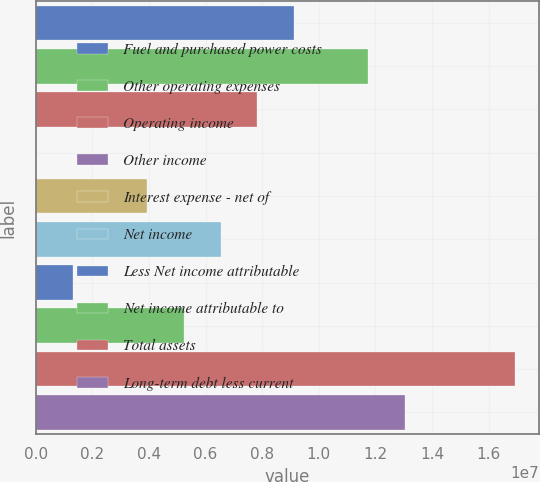Convert chart. <chart><loc_0><loc_0><loc_500><loc_500><bar_chart><fcel>Fuel and purchased power costs<fcel>Other operating expenses<fcel>Operating income<fcel>Other income<fcel>Interest expense - net of<fcel>Net income<fcel>Less Net income attributable<fcel>Net income attributable to<fcel>Total assets<fcel>Long-term debt less current<nl><fcel>9.13006e+06<fcel>1.17315e+07<fcel>7.82933e+06<fcel>24974<fcel>3.92715e+06<fcel>6.52861e+06<fcel>1.3257e+06<fcel>5.22788e+06<fcel>1.69344e+07<fcel>1.30322e+07<nl></chart> 